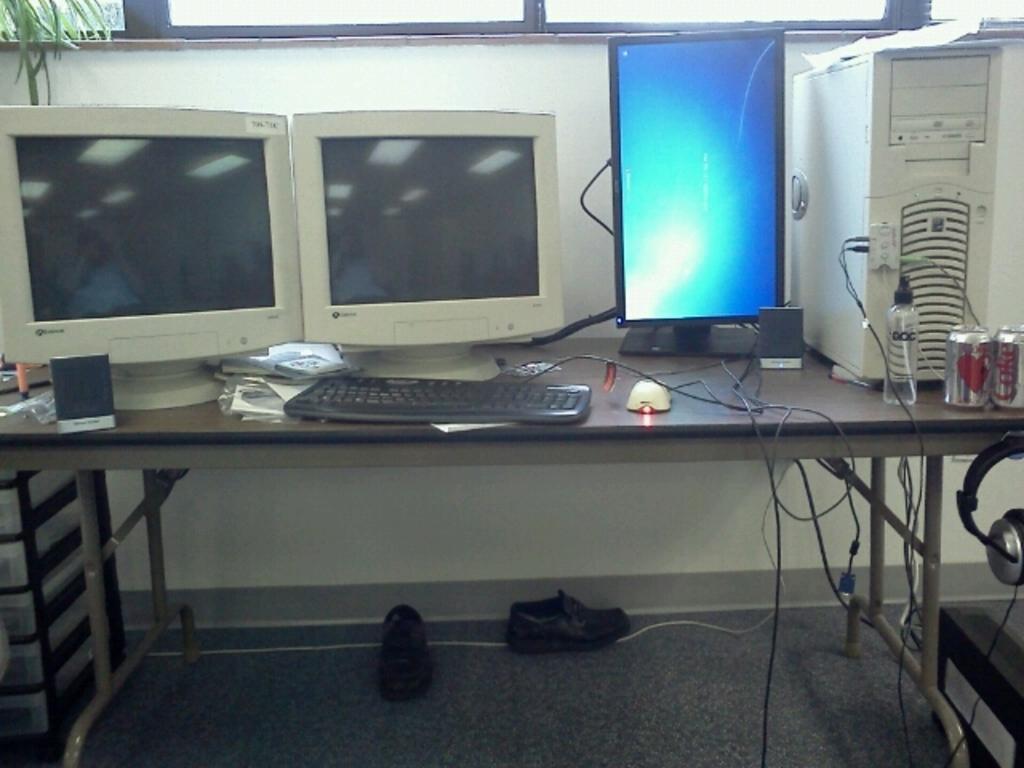Please provide a concise description of this image. In this picture we can see a table on the floor, on this table we can see monitors, keyboard, mouse, headphone and some objects, here we can see shoes on the floor. 